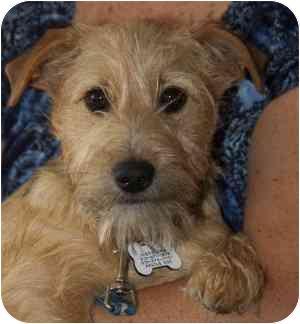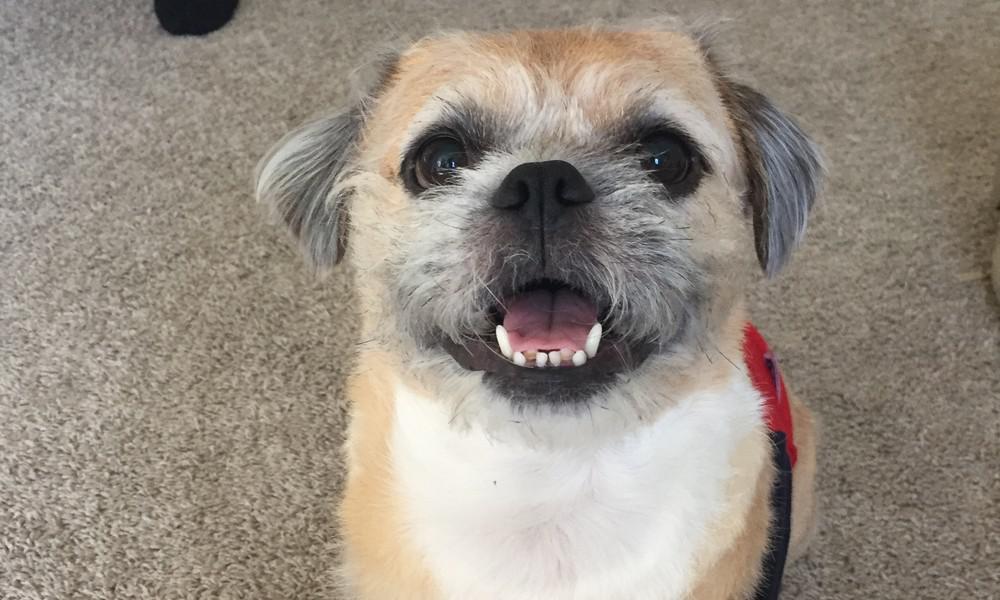The first image is the image on the left, the second image is the image on the right. Examine the images to the left and right. Is the description "A medallion can be seen hanging from the collar of the dog in the image on the left." accurate? Answer yes or no. Yes. 